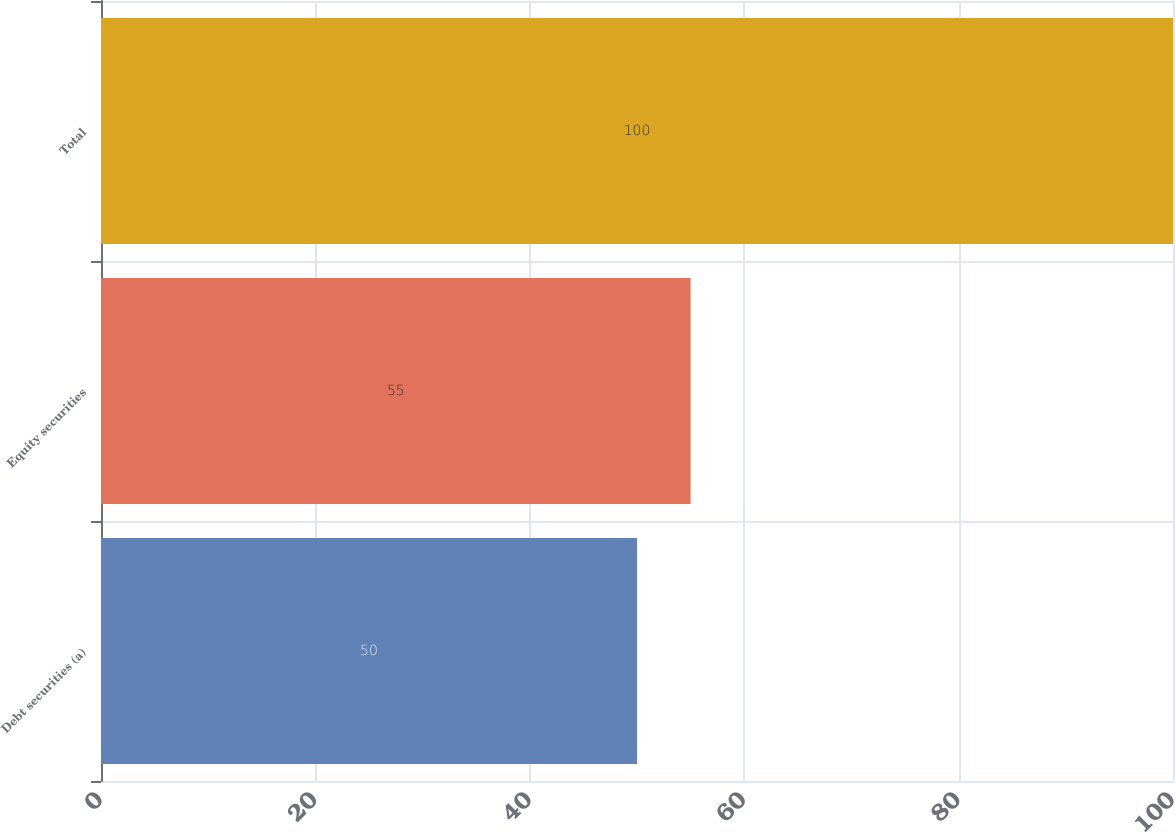<chart> <loc_0><loc_0><loc_500><loc_500><bar_chart><fcel>Debt securities (a)<fcel>Equity securities<fcel>Total<nl><fcel>50<fcel>55<fcel>100<nl></chart> 